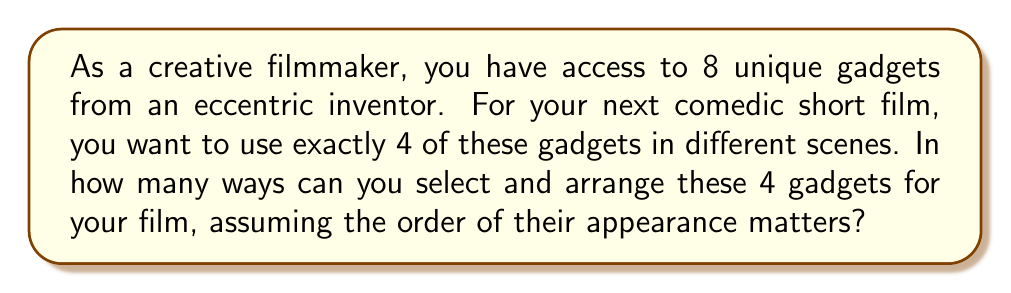Help me with this question. Let's approach this step-by-step:

1) This problem involves selecting 4 gadgets out of 8 and arranging them in a specific order. This is a permutation problem.

2) We use the permutation formula:
   $P(n,r) = \frac{n!}{(n-r)!}$
   
   Where $n$ is the total number of gadgets (8) and $r$ is the number we're selecting (4).

3) Plugging in our values:
   $P(8,4) = \frac{8!}{(8-4)!} = \frac{8!}{4!}$

4) Let's expand this:
   $$\frac{8 \cdot 7 \cdot 6 \cdot 5 \cdot 4!}{4!}$$

5) The $4!$ cancels out in the numerator and denominator:
   $$8 \cdot 7 \cdot 6 \cdot 5 = 1680$$

Therefore, there are 1680 different ways to select and arrange 4 gadgets out of 8 for your comedic short film.
Answer: 1680 